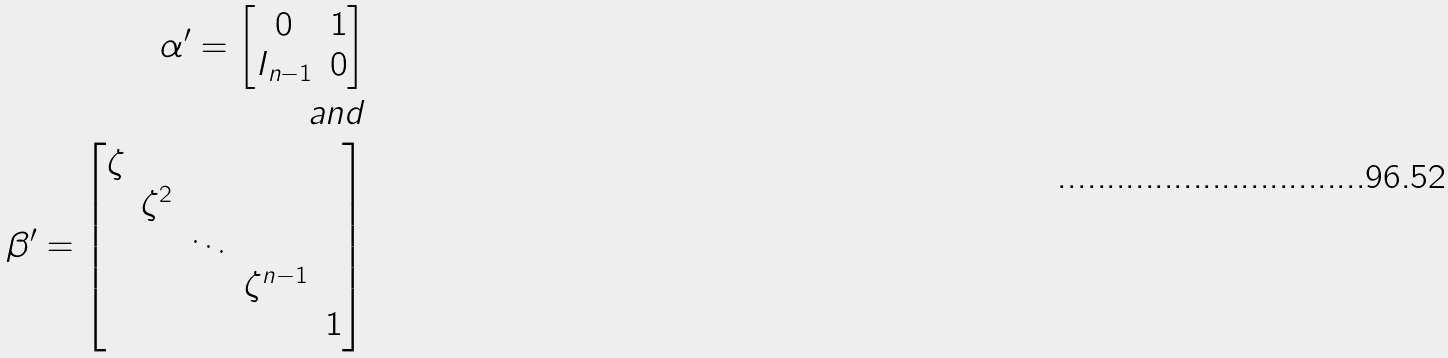Convert formula to latex. <formula><loc_0><loc_0><loc_500><loc_500>\alpha ^ { \prime } = \begin{bmatrix} 0 & 1 \\ I _ { n - 1 } & 0 \end{bmatrix} \\ a n d \\ \beta ^ { \prime } = \begin{bmatrix} \zeta & & & & \\ & \zeta ^ { 2 } & & & \\ & & \ddots & & \\ & & & \zeta ^ { n - 1 } & \\ & & & & 1 \end{bmatrix}</formula> 